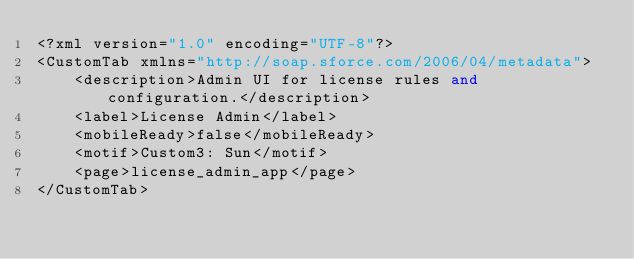<code> <loc_0><loc_0><loc_500><loc_500><_SQL_><?xml version="1.0" encoding="UTF-8"?>
<CustomTab xmlns="http://soap.sforce.com/2006/04/metadata">
    <description>Admin UI for license rules and configuration.</description>
    <label>License Admin</label>
    <mobileReady>false</mobileReady>
    <motif>Custom3: Sun</motif>
    <page>license_admin_app</page>
</CustomTab>
</code> 